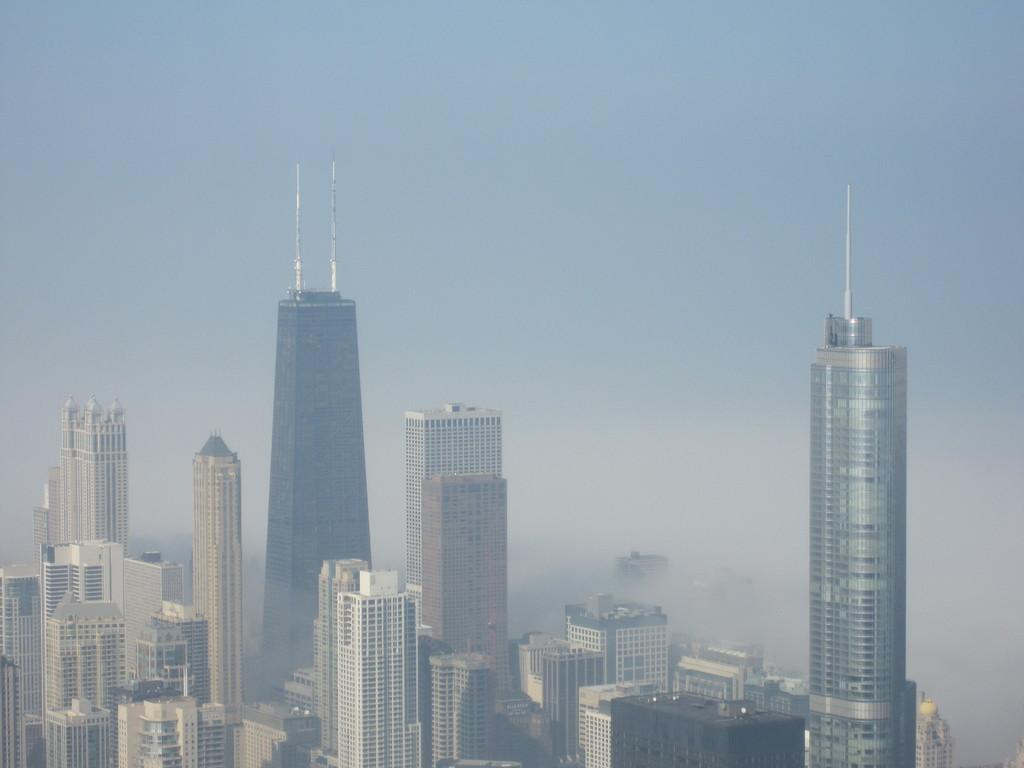What type of structures can be seen in the image? There are buildings in the image. What part of the natural environment is visible in the image? The sky is visible in the background of the image. What brand of toothpaste is being advertised on the buildings in the image? There is no toothpaste or advertisement present in the image; it only features buildings and the sky. 